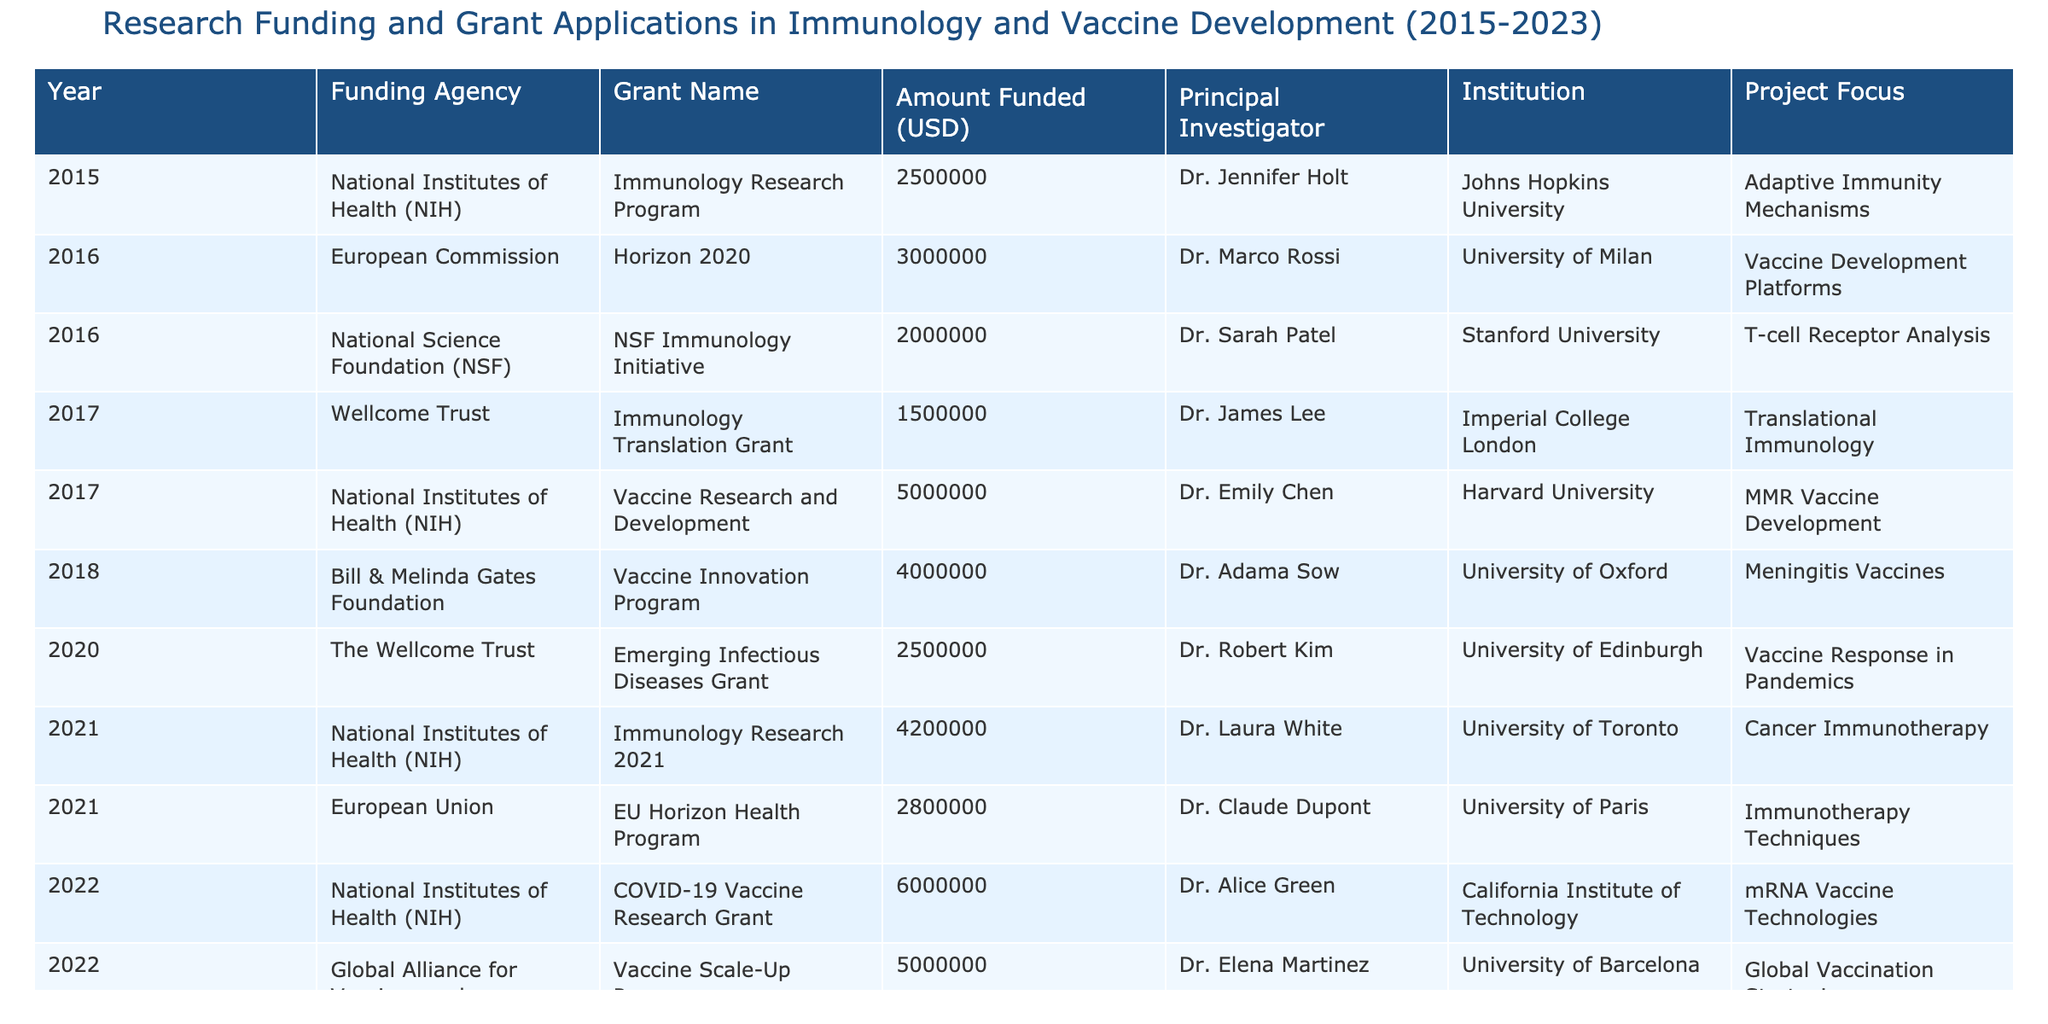What was the highest amount funded in a single year? The highest single grant amount listed is $6,000,000 for the COVID-19 Vaccine Research Grant in 2022.
Answer: $6,000,000 Which institution received funding for T-cell receptor analysis? The Stanford University, led by Dr. Sarah Patel, received $2,000,000 for T-cell receptor analysis in 2016.
Answer: Stanford University How many grants were awarded in the year 2021? In 2021, there were two grants awarded: one from the NIH and one from the European Union.
Answer: 2 What is the total amount funded for vaccine-related projects from 2015 to 2023? The total funding for vaccine-related projects is $25,000,000, calculated by adding the amounts for vaccine-focused grants only: $5,000,000 (2017) + $4,000,000 (2018) + $2,500,000 (2020) + $6,000,000 (2022) + $5,000,000 (2023) = $25,500,000.
Answer: $25,500,000 Was there any funding for cancer immunotherapy? Yes, the NIH provided $4,200,000 for cancer immunotherapy in 2021.
Answer: Yes Which principal investigator received the most total funding between their grants? Dr. Alice Green received a total of $6,000,000 for the COVID-19 Vaccine Research Grant in 2022, the highest amount for a single grant in the table.
Answer: Dr. Alice Green In which year did the fewest grants get funded? The year with the fewest grants was 2015, with only one grant awarded.
Answer: 2015 What is the average amount funded per grant from 2015 to 2023? The total amount funded across all grants is $35,500,000, and there were 12 total grants. Thus, the average amount funded per grant is $35,500,000 / 12 ≈ $2,958,333.33.
Answer: $2,958,333.33 Which funding agency supported research on innovations in immunotherapy in 2023? The National Institutes of Health (NIH) supported the Immunology and Vaccines Initiative in 2023.
Answer: NIH How much more funding did the National Institutes of Health provide compared to the European Commission over the years? The NIH provided $25,200,000 across 6 grants while the European Commission provided $3,000,000 across 1 grant, resulting in a difference of $22,200,000.
Answer: $22,200,000 